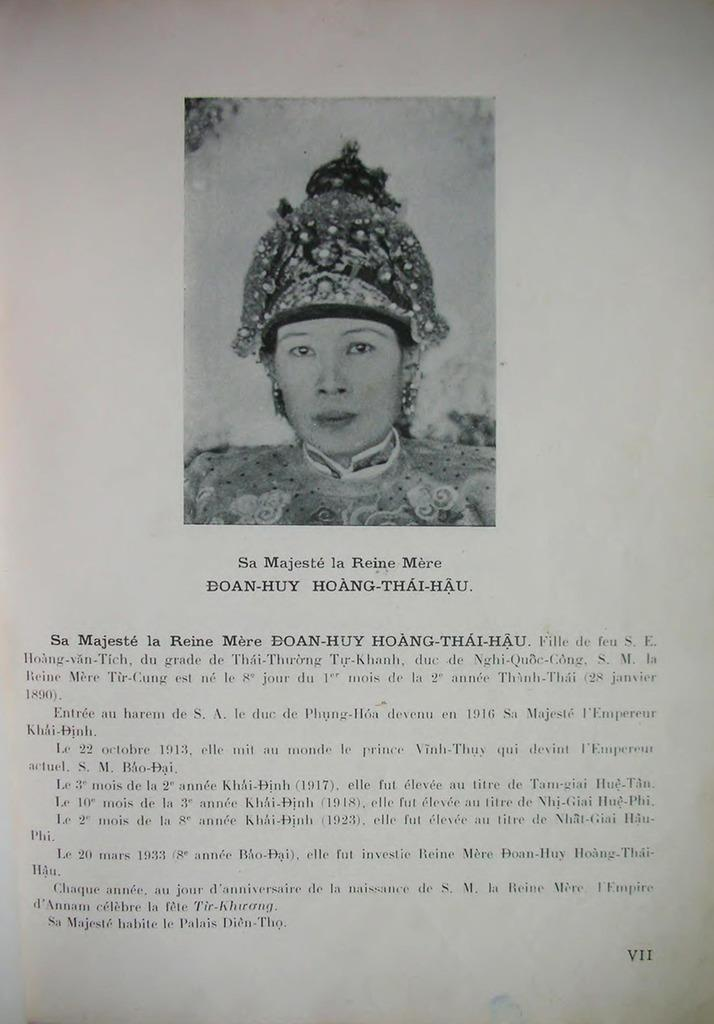What is the main subject of the image? There is a woman's face in the center of the image. Is there any text present in the image? Yes, there is text at the bottom of the image. What type of attempt is the woman making in the image? There is no indication of an attempt in the image; it simply features a woman's face and text at the bottom. Is the woman playing a game or instrument in the image? A: There is no indication of the woman playing a game or instrument in the image. 